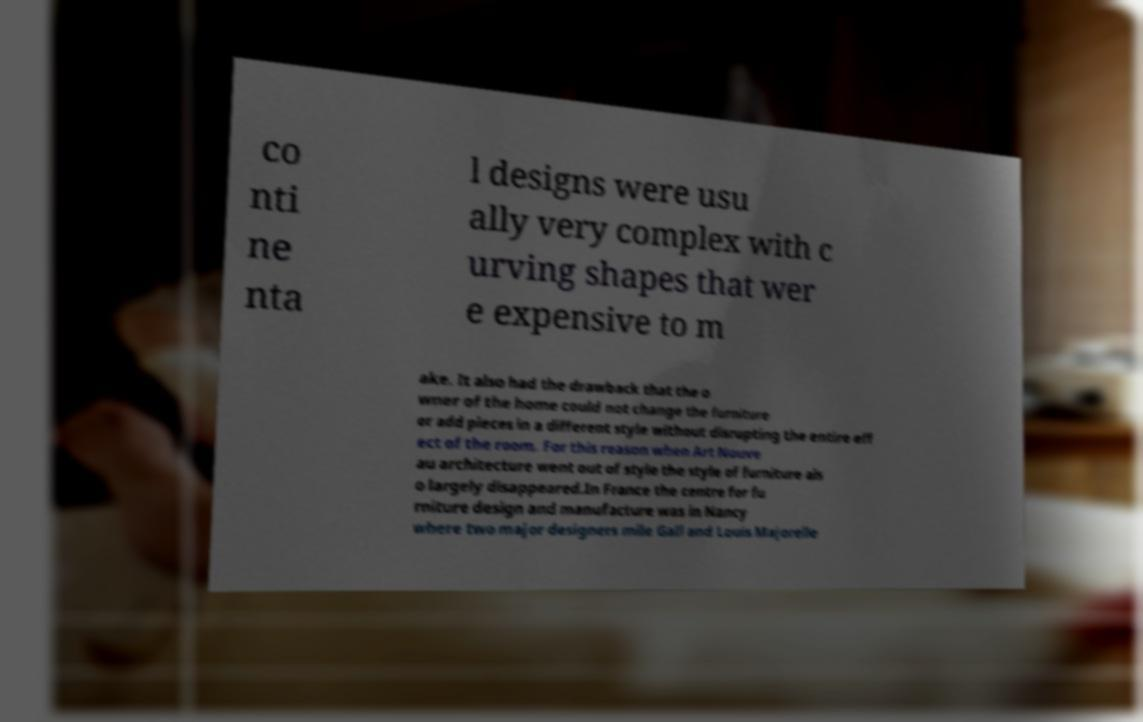Could you extract and type out the text from this image? co nti ne nta l designs were usu ally very complex with c urving shapes that wer e expensive to m ake. It also had the drawback that the o wner of the home could not change the furniture or add pieces in a different style without disrupting the entire eff ect of the room. For this reason when Art Nouve au architecture went out of style the style of furniture als o largely disappeared.In France the centre for fu rniture design and manufacture was in Nancy where two major designers mile Gall and Louis Majorelle 